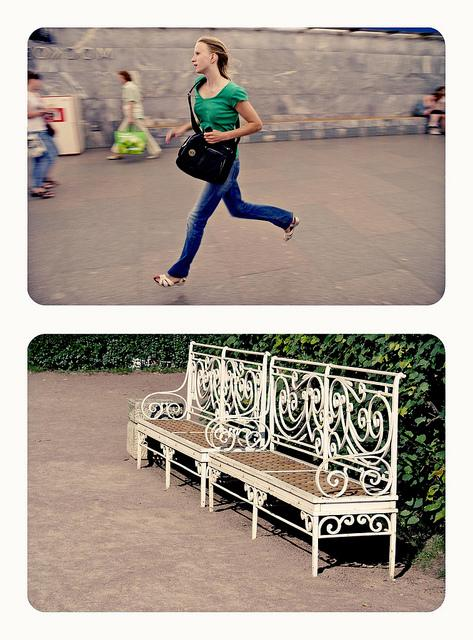Which country invented free public benches? france 